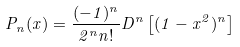<formula> <loc_0><loc_0><loc_500><loc_500>P _ { n } ( x ) = \frac { ( - 1 ) ^ { n } } { 2 ^ { n } n ! } D ^ { n } \left [ ( 1 - x ^ { 2 } ) ^ { n } \right ]</formula> 